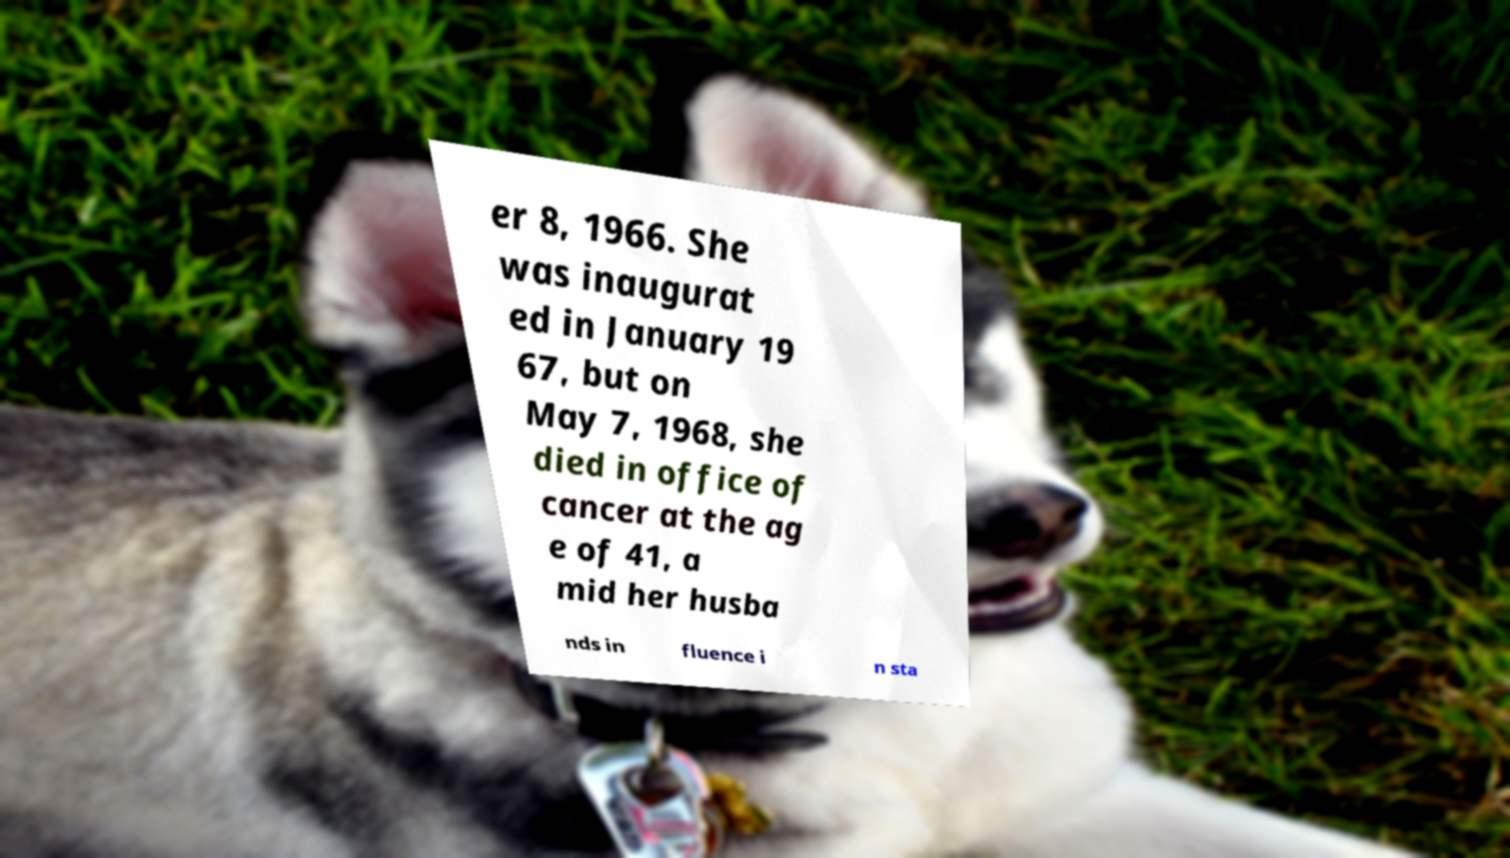I need the written content from this picture converted into text. Can you do that? er 8, 1966. She was inaugurat ed in January 19 67, but on May 7, 1968, she died in office of cancer at the ag e of 41, a mid her husba nds in fluence i n sta 